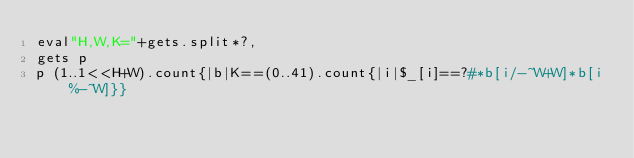<code> <loc_0><loc_0><loc_500><loc_500><_Ruby_>eval"H,W,K="+gets.split*?,
gets p
p (1..1<<H+W).count{|b|K==(0..41).count{|i|$_[i]==?#*b[i/-~W+W]*b[i%-~W]}}</code> 